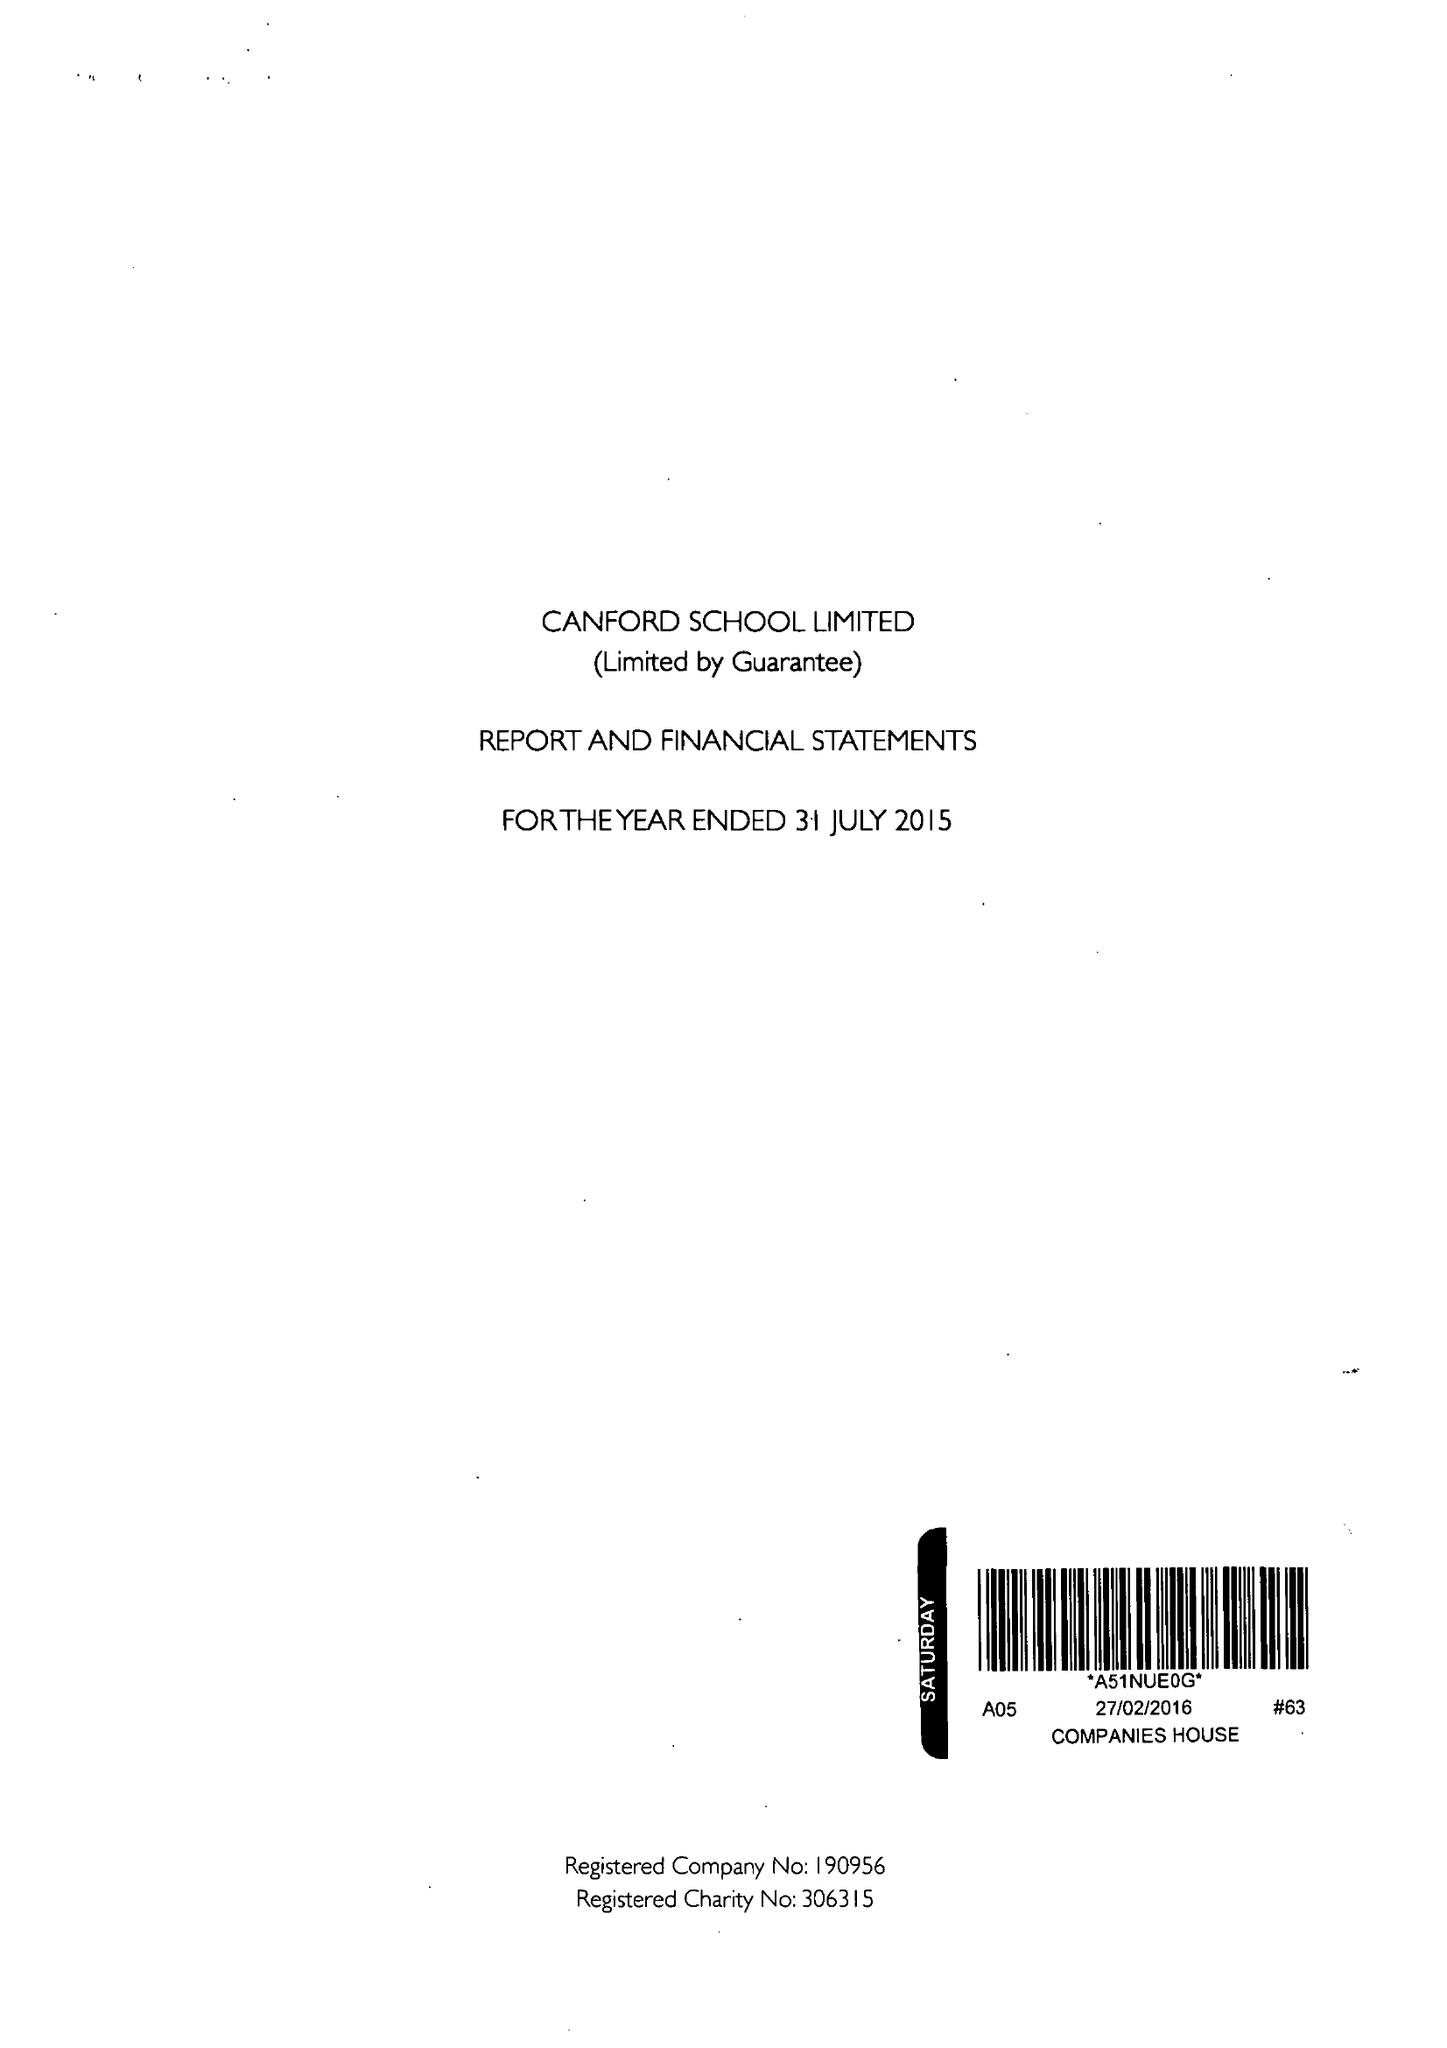What is the value for the address__post_town?
Answer the question using a single word or phrase. WIMBORNE 